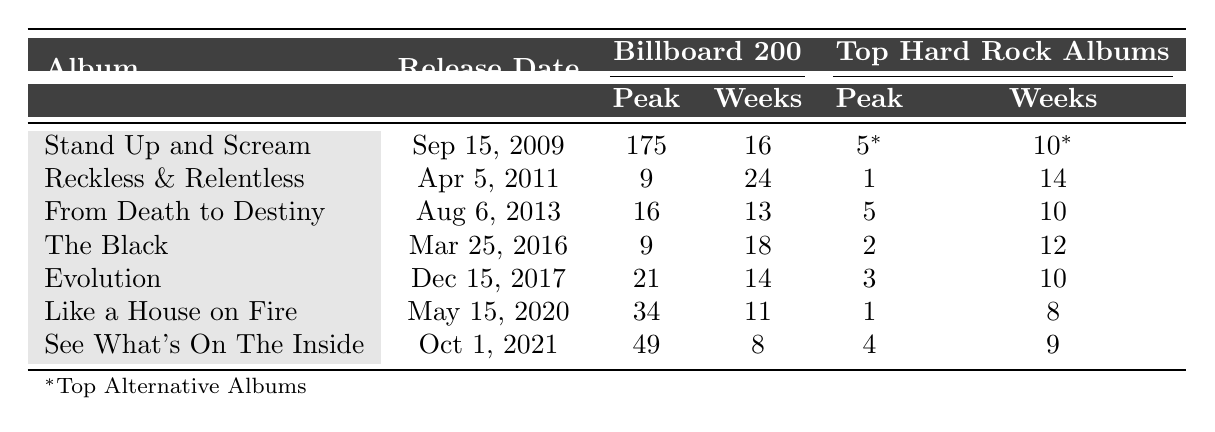What is the release date of "Reckless & Relentless"? "Reckless & Relentless" is listed in the table with the release date mentioned next to it, which is April 5, 2011.
Answer: April 5, 2011 Which album reached the highest peak position on the Top Hard Rock Albums chart? By examining the chart performance under Top Hard Rock Albums, "Reckless & Relentless" is shown with a peak position of 1, making it the highest peak.
Answer: Reckless & Relentless How many weeks did "See What's On The Inside" spend on the Billboard 200 chart? The table shows "See What's On The Inside" has spent 8 weeks on the Billboard 200 chart.
Answer: 8 weeks What is the average peak position for Asking Alexandria albums on the Billboard 200 chart? The peak positions for the albums are 175, 9, 16, 9, 21, 34, and 49. Adding these gives 175 + 9 + 16 + 9 + 21 + 34 + 49 = 313. There are 7 albums, so the average is 313/7 = 44.71, which we can round to 45.
Answer: 45 Did "Like a House on Fire" spend more weeks on the Billboard 200 than "Evolution"? "Like a House on Fire" spent 11 weeks on the Billboard 200 while "Evolution" spent 14 weeks. Since 11 is less than 14, the answer is no.
Answer: No Which album had the most weeks on the Top Hard Rock Albums chart? The table shows "Reckless & Relentless" has 14 weeks on the Top Hard Rock Albums chart, which is the highest compared to other albums.
Answer: Reckless & Relentless What is the difference in peak position on the Billboard 200 between "The Black" and "From Death to Destiny"? "The Black" peaked at 9 and "From Death to Destiny" peaked at 16. The difference in position is calculated as 16 - 9 = 7.
Answer: 7 Was "Stand Up and Scream" the first album released by Asking Alexandria? The release date of "Stand Up and Scream" is September 15, 2009, which is before all other albums in the table. Therefore, it was indeed the first album.
Answer: Yes What is the sum of the weeks spent on the Top Hard Rock Albums for all albums? The weeks listed for Top Hard Rock Albums are 10, 14, 10, 12, 10, 8, and 9. Summing these gives 10 + 14 + 10 + 12 + 10 + 8 + 9 = 73.
Answer: 73 Which album was released last? The release dates indicate that "See What's On The Inside" was released last on October 1, 2021, as it is the most recent entry in the list.
Answer: See What's On The Inside 